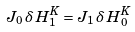<formula> <loc_0><loc_0><loc_500><loc_500>J _ { 0 } \, \delta \, H _ { 1 } ^ { K } = J _ { 1 } \, \delta \, H _ { 0 } ^ { K }</formula> 